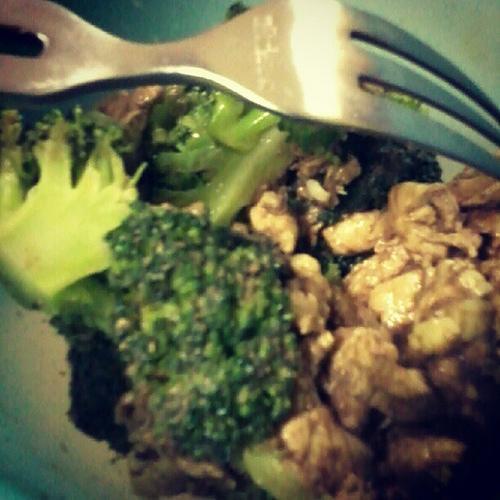How many forks are there?
Give a very brief answer. 1. 